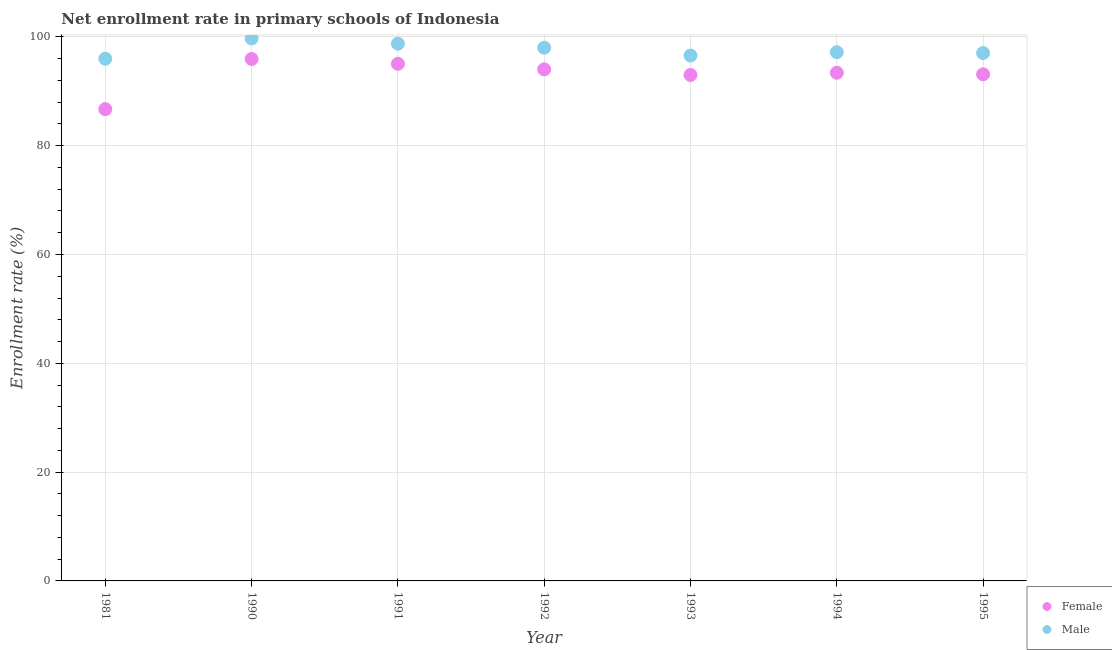What is the enrollment rate of female students in 1994?
Offer a very short reply. 93.41. Across all years, what is the maximum enrollment rate of male students?
Keep it short and to the point. 99.72. Across all years, what is the minimum enrollment rate of male students?
Give a very brief answer. 95.99. In which year was the enrollment rate of male students minimum?
Offer a very short reply. 1981. What is the total enrollment rate of male students in the graph?
Give a very brief answer. 683.25. What is the difference between the enrollment rate of female students in 1992 and that in 1993?
Give a very brief answer. 1.04. What is the difference between the enrollment rate of female students in 1981 and the enrollment rate of male students in 1994?
Your response must be concise. -10.47. What is the average enrollment rate of female students per year?
Give a very brief answer. 93.04. In the year 1993, what is the difference between the enrollment rate of male students and enrollment rate of female students?
Make the answer very short. 3.58. What is the ratio of the enrollment rate of male students in 1990 to that in 1993?
Keep it short and to the point. 1.03. Is the difference between the enrollment rate of female students in 1990 and 1993 greater than the difference between the enrollment rate of male students in 1990 and 1993?
Your answer should be very brief. No. What is the difference between the highest and the second highest enrollment rate of male students?
Provide a succinct answer. 0.97. What is the difference between the highest and the lowest enrollment rate of male students?
Provide a short and direct response. 3.73. Does the enrollment rate of female students monotonically increase over the years?
Ensure brevity in your answer.  No. Is the enrollment rate of female students strictly greater than the enrollment rate of male students over the years?
Keep it short and to the point. No. Is the enrollment rate of male students strictly less than the enrollment rate of female students over the years?
Your answer should be compact. No. How many dotlines are there?
Provide a short and direct response. 2. How many years are there in the graph?
Give a very brief answer. 7. Where does the legend appear in the graph?
Ensure brevity in your answer.  Bottom right. How many legend labels are there?
Keep it short and to the point. 2. What is the title of the graph?
Make the answer very short. Net enrollment rate in primary schools of Indonesia. What is the label or title of the X-axis?
Ensure brevity in your answer.  Year. What is the label or title of the Y-axis?
Give a very brief answer. Enrollment rate (%). What is the Enrollment rate (%) of Female in 1981?
Offer a very short reply. 86.71. What is the Enrollment rate (%) in Male in 1981?
Provide a succinct answer. 95.99. What is the Enrollment rate (%) in Female in 1990?
Ensure brevity in your answer.  95.94. What is the Enrollment rate (%) of Male in 1990?
Your response must be concise. 99.72. What is the Enrollment rate (%) of Female in 1991?
Your response must be concise. 95.05. What is the Enrollment rate (%) in Male in 1991?
Make the answer very short. 98.75. What is the Enrollment rate (%) in Female in 1992?
Offer a very short reply. 94.03. What is the Enrollment rate (%) in Male in 1992?
Offer a very short reply. 98.01. What is the Enrollment rate (%) of Female in 1993?
Offer a terse response. 92.99. What is the Enrollment rate (%) of Male in 1993?
Your response must be concise. 96.57. What is the Enrollment rate (%) of Female in 1994?
Give a very brief answer. 93.41. What is the Enrollment rate (%) in Male in 1994?
Your answer should be compact. 97.18. What is the Enrollment rate (%) in Female in 1995?
Ensure brevity in your answer.  93.12. What is the Enrollment rate (%) of Male in 1995?
Offer a very short reply. 97.03. Across all years, what is the maximum Enrollment rate (%) in Female?
Your answer should be very brief. 95.94. Across all years, what is the maximum Enrollment rate (%) in Male?
Give a very brief answer. 99.72. Across all years, what is the minimum Enrollment rate (%) in Female?
Offer a terse response. 86.71. Across all years, what is the minimum Enrollment rate (%) of Male?
Make the answer very short. 95.99. What is the total Enrollment rate (%) of Female in the graph?
Ensure brevity in your answer.  651.25. What is the total Enrollment rate (%) of Male in the graph?
Make the answer very short. 683.25. What is the difference between the Enrollment rate (%) of Female in 1981 and that in 1990?
Your response must be concise. -9.23. What is the difference between the Enrollment rate (%) of Male in 1981 and that in 1990?
Your answer should be compact. -3.73. What is the difference between the Enrollment rate (%) in Female in 1981 and that in 1991?
Provide a short and direct response. -8.34. What is the difference between the Enrollment rate (%) in Male in 1981 and that in 1991?
Make the answer very short. -2.76. What is the difference between the Enrollment rate (%) of Female in 1981 and that in 1992?
Provide a succinct answer. -7.32. What is the difference between the Enrollment rate (%) of Male in 1981 and that in 1992?
Keep it short and to the point. -2.01. What is the difference between the Enrollment rate (%) of Female in 1981 and that in 1993?
Make the answer very short. -6.28. What is the difference between the Enrollment rate (%) of Male in 1981 and that in 1993?
Give a very brief answer. -0.58. What is the difference between the Enrollment rate (%) in Female in 1981 and that in 1994?
Your response must be concise. -6.69. What is the difference between the Enrollment rate (%) in Male in 1981 and that in 1994?
Provide a succinct answer. -1.19. What is the difference between the Enrollment rate (%) in Female in 1981 and that in 1995?
Your answer should be compact. -6.41. What is the difference between the Enrollment rate (%) in Male in 1981 and that in 1995?
Your answer should be very brief. -1.03. What is the difference between the Enrollment rate (%) in Female in 1990 and that in 1991?
Offer a terse response. 0.89. What is the difference between the Enrollment rate (%) in Male in 1990 and that in 1991?
Your answer should be compact. 0.97. What is the difference between the Enrollment rate (%) in Female in 1990 and that in 1992?
Make the answer very short. 1.91. What is the difference between the Enrollment rate (%) in Male in 1990 and that in 1992?
Make the answer very short. 1.71. What is the difference between the Enrollment rate (%) in Female in 1990 and that in 1993?
Your answer should be compact. 2.95. What is the difference between the Enrollment rate (%) in Male in 1990 and that in 1993?
Make the answer very short. 3.15. What is the difference between the Enrollment rate (%) of Female in 1990 and that in 1994?
Your answer should be compact. 2.53. What is the difference between the Enrollment rate (%) in Male in 1990 and that in 1994?
Keep it short and to the point. 2.54. What is the difference between the Enrollment rate (%) in Female in 1990 and that in 1995?
Ensure brevity in your answer.  2.82. What is the difference between the Enrollment rate (%) in Male in 1990 and that in 1995?
Your response must be concise. 2.69. What is the difference between the Enrollment rate (%) in Female in 1991 and that in 1992?
Provide a short and direct response. 1.02. What is the difference between the Enrollment rate (%) in Male in 1991 and that in 1992?
Make the answer very short. 0.74. What is the difference between the Enrollment rate (%) of Female in 1991 and that in 1993?
Make the answer very short. 2.05. What is the difference between the Enrollment rate (%) of Male in 1991 and that in 1993?
Offer a very short reply. 2.18. What is the difference between the Enrollment rate (%) of Female in 1991 and that in 1994?
Your answer should be very brief. 1.64. What is the difference between the Enrollment rate (%) in Male in 1991 and that in 1994?
Make the answer very short. 1.57. What is the difference between the Enrollment rate (%) in Female in 1991 and that in 1995?
Your answer should be compact. 1.93. What is the difference between the Enrollment rate (%) of Male in 1991 and that in 1995?
Offer a terse response. 1.72. What is the difference between the Enrollment rate (%) of Female in 1992 and that in 1993?
Offer a terse response. 1.04. What is the difference between the Enrollment rate (%) in Male in 1992 and that in 1993?
Keep it short and to the point. 1.44. What is the difference between the Enrollment rate (%) of Female in 1992 and that in 1994?
Give a very brief answer. 0.63. What is the difference between the Enrollment rate (%) of Male in 1992 and that in 1994?
Your answer should be compact. 0.83. What is the difference between the Enrollment rate (%) of Female in 1992 and that in 1995?
Ensure brevity in your answer.  0.91. What is the difference between the Enrollment rate (%) in Female in 1993 and that in 1994?
Your answer should be compact. -0.41. What is the difference between the Enrollment rate (%) of Male in 1993 and that in 1994?
Offer a terse response. -0.61. What is the difference between the Enrollment rate (%) of Female in 1993 and that in 1995?
Give a very brief answer. -0.13. What is the difference between the Enrollment rate (%) of Male in 1993 and that in 1995?
Give a very brief answer. -0.46. What is the difference between the Enrollment rate (%) of Female in 1994 and that in 1995?
Provide a short and direct response. 0.28. What is the difference between the Enrollment rate (%) of Male in 1994 and that in 1995?
Provide a succinct answer. 0.15. What is the difference between the Enrollment rate (%) in Female in 1981 and the Enrollment rate (%) in Male in 1990?
Your answer should be very brief. -13.01. What is the difference between the Enrollment rate (%) of Female in 1981 and the Enrollment rate (%) of Male in 1991?
Give a very brief answer. -12.04. What is the difference between the Enrollment rate (%) of Female in 1981 and the Enrollment rate (%) of Male in 1992?
Offer a terse response. -11.29. What is the difference between the Enrollment rate (%) of Female in 1981 and the Enrollment rate (%) of Male in 1993?
Your answer should be very brief. -9.86. What is the difference between the Enrollment rate (%) in Female in 1981 and the Enrollment rate (%) in Male in 1994?
Your answer should be compact. -10.47. What is the difference between the Enrollment rate (%) in Female in 1981 and the Enrollment rate (%) in Male in 1995?
Provide a succinct answer. -10.32. What is the difference between the Enrollment rate (%) in Female in 1990 and the Enrollment rate (%) in Male in 1991?
Give a very brief answer. -2.81. What is the difference between the Enrollment rate (%) in Female in 1990 and the Enrollment rate (%) in Male in 1992?
Provide a short and direct response. -2.07. What is the difference between the Enrollment rate (%) of Female in 1990 and the Enrollment rate (%) of Male in 1993?
Provide a short and direct response. -0.63. What is the difference between the Enrollment rate (%) of Female in 1990 and the Enrollment rate (%) of Male in 1994?
Ensure brevity in your answer.  -1.24. What is the difference between the Enrollment rate (%) of Female in 1990 and the Enrollment rate (%) of Male in 1995?
Your answer should be compact. -1.09. What is the difference between the Enrollment rate (%) of Female in 1991 and the Enrollment rate (%) of Male in 1992?
Offer a terse response. -2.96. What is the difference between the Enrollment rate (%) of Female in 1991 and the Enrollment rate (%) of Male in 1993?
Offer a very short reply. -1.52. What is the difference between the Enrollment rate (%) in Female in 1991 and the Enrollment rate (%) in Male in 1994?
Your answer should be compact. -2.13. What is the difference between the Enrollment rate (%) of Female in 1991 and the Enrollment rate (%) of Male in 1995?
Offer a terse response. -1.98. What is the difference between the Enrollment rate (%) of Female in 1992 and the Enrollment rate (%) of Male in 1993?
Your response must be concise. -2.54. What is the difference between the Enrollment rate (%) in Female in 1992 and the Enrollment rate (%) in Male in 1994?
Give a very brief answer. -3.15. What is the difference between the Enrollment rate (%) in Female in 1992 and the Enrollment rate (%) in Male in 1995?
Your answer should be very brief. -3. What is the difference between the Enrollment rate (%) in Female in 1993 and the Enrollment rate (%) in Male in 1994?
Your response must be concise. -4.19. What is the difference between the Enrollment rate (%) in Female in 1993 and the Enrollment rate (%) in Male in 1995?
Your answer should be compact. -4.03. What is the difference between the Enrollment rate (%) of Female in 1994 and the Enrollment rate (%) of Male in 1995?
Your answer should be compact. -3.62. What is the average Enrollment rate (%) of Female per year?
Your response must be concise. 93.04. What is the average Enrollment rate (%) in Male per year?
Provide a succinct answer. 97.61. In the year 1981, what is the difference between the Enrollment rate (%) in Female and Enrollment rate (%) in Male?
Give a very brief answer. -9.28. In the year 1990, what is the difference between the Enrollment rate (%) of Female and Enrollment rate (%) of Male?
Give a very brief answer. -3.78. In the year 1991, what is the difference between the Enrollment rate (%) of Female and Enrollment rate (%) of Male?
Give a very brief answer. -3.7. In the year 1992, what is the difference between the Enrollment rate (%) of Female and Enrollment rate (%) of Male?
Ensure brevity in your answer.  -3.97. In the year 1993, what is the difference between the Enrollment rate (%) of Female and Enrollment rate (%) of Male?
Offer a terse response. -3.58. In the year 1994, what is the difference between the Enrollment rate (%) in Female and Enrollment rate (%) in Male?
Keep it short and to the point. -3.77. In the year 1995, what is the difference between the Enrollment rate (%) of Female and Enrollment rate (%) of Male?
Give a very brief answer. -3.91. What is the ratio of the Enrollment rate (%) in Female in 1981 to that in 1990?
Give a very brief answer. 0.9. What is the ratio of the Enrollment rate (%) in Male in 1981 to that in 1990?
Provide a short and direct response. 0.96. What is the ratio of the Enrollment rate (%) in Female in 1981 to that in 1991?
Keep it short and to the point. 0.91. What is the ratio of the Enrollment rate (%) of Male in 1981 to that in 1991?
Give a very brief answer. 0.97. What is the ratio of the Enrollment rate (%) of Female in 1981 to that in 1992?
Your answer should be compact. 0.92. What is the ratio of the Enrollment rate (%) of Male in 1981 to that in 1992?
Offer a terse response. 0.98. What is the ratio of the Enrollment rate (%) of Female in 1981 to that in 1993?
Ensure brevity in your answer.  0.93. What is the ratio of the Enrollment rate (%) of Male in 1981 to that in 1993?
Make the answer very short. 0.99. What is the ratio of the Enrollment rate (%) of Female in 1981 to that in 1994?
Keep it short and to the point. 0.93. What is the ratio of the Enrollment rate (%) in Male in 1981 to that in 1994?
Your answer should be compact. 0.99. What is the ratio of the Enrollment rate (%) in Female in 1981 to that in 1995?
Make the answer very short. 0.93. What is the ratio of the Enrollment rate (%) in Male in 1981 to that in 1995?
Your response must be concise. 0.99. What is the ratio of the Enrollment rate (%) in Female in 1990 to that in 1991?
Your response must be concise. 1.01. What is the ratio of the Enrollment rate (%) of Male in 1990 to that in 1991?
Provide a succinct answer. 1.01. What is the ratio of the Enrollment rate (%) of Female in 1990 to that in 1992?
Your answer should be very brief. 1.02. What is the ratio of the Enrollment rate (%) in Male in 1990 to that in 1992?
Your answer should be very brief. 1.02. What is the ratio of the Enrollment rate (%) of Female in 1990 to that in 1993?
Your answer should be compact. 1.03. What is the ratio of the Enrollment rate (%) in Male in 1990 to that in 1993?
Your answer should be very brief. 1.03. What is the ratio of the Enrollment rate (%) of Female in 1990 to that in 1994?
Give a very brief answer. 1.03. What is the ratio of the Enrollment rate (%) in Male in 1990 to that in 1994?
Keep it short and to the point. 1.03. What is the ratio of the Enrollment rate (%) of Female in 1990 to that in 1995?
Give a very brief answer. 1.03. What is the ratio of the Enrollment rate (%) in Male in 1990 to that in 1995?
Ensure brevity in your answer.  1.03. What is the ratio of the Enrollment rate (%) in Female in 1991 to that in 1992?
Provide a short and direct response. 1.01. What is the ratio of the Enrollment rate (%) in Male in 1991 to that in 1992?
Give a very brief answer. 1.01. What is the ratio of the Enrollment rate (%) of Female in 1991 to that in 1993?
Offer a very short reply. 1.02. What is the ratio of the Enrollment rate (%) of Male in 1991 to that in 1993?
Provide a succinct answer. 1.02. What is the ratio of the Enrollment rate (%) of Female in 1991 to that in 1994?
Provide a short and direct response. 1.02. What is the ratio of the Enrollment rate (%) of Male in 1991 to that in 1994?
Your answer should be compact. 1.02. What is the ratio of the Enrollment rate (%) of Female in 1991 to that in 1995?
Your answer should be compact. 1.02. What is the ratio of the Enrollment rate (%) of Male in 1991 to that in 1995?
Your answer should be very brief. 1.02. What is the ratio of the Enrollment rate (%) in Female in 1992 to that in 1993?
Your response must be concise. 1.01. What is the ratio of the Enrollment rate (%) of Male in 1992 to that in 1993?
Provide a succinct answer. 1.01. What is the ratio of the Enrollment rate (%) of Male in 1992 to that in 1994?
Your response must be concise. 1.01. What is the ratio of the Enrollment rate (%) of Female in 1992 to that in 1995?
Your answer should be compact. 1.01. What is the ratio of the Enrollment rate (%) of Female in 1993 to that in 1994?
Keep it short and to the point. 1. What is the ratio of the Enrollment rate (%) in Male in 1993 to that in 1994?
Give a very brief answer. 0.99. What is the ratio of the Enrollment rate (%) in Female in 1993 to that in 1995?
Provide a short and direct response. 1. What is the ratio of the Enrollment rate (%) in Male in 1993 to that in 1995?
Offer a very short reply. 1. What is the ratio of the Enrollment rate (%) in Female in 1994 to that in 1995?
Your answer should be compact. 1. What is the ratio of the Enrollment rate (%) in Male in 1994 to that in 1995?
Make the answer very short. 1. What is the difference between the highest and the second highest Enrollment rate (%) in Female?
Offer a very short reply. 0.89. What is the difference between the highest and the second highest Enrollment rate (%) of Male?
Make the answer very short. 0.97. What is the difference between the highest and the lowest Enrollment rate (%) in Female?
Provide a short and direct response. 9.23. What is the difference between the highest and the lowest Enrollment rate (%) in Male?
Ensure brevity in your answer.  3.73. 